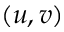<formula> <loc_0><loc_0><loc_500><loc_500>( u , v )</formula> 